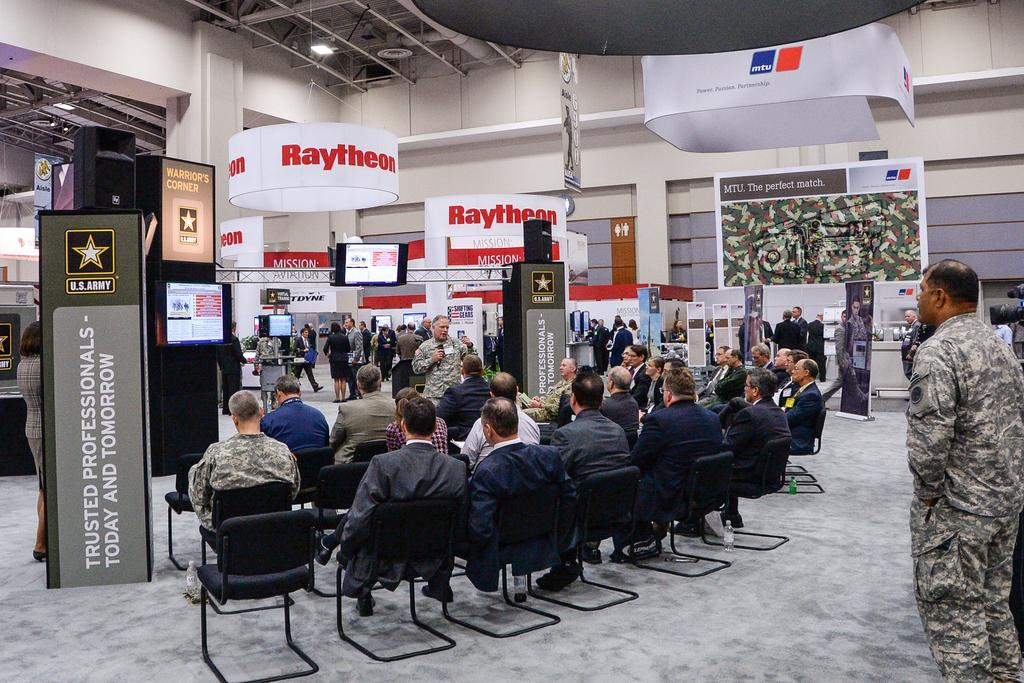Where is the image taken? The image is taken in a hall. What are the people in the image doing? The people are sitting on chairs. Who is the man holding a microphone and what is he doing? The man is holding a microphone and talking. What can be seen in the background of the image? There is a wall and a banner in the background. What type of reaction can be seen on the lawyer's face in the image? There is no lawyer present in the image, and therefore no reaction can be observed on a lawyer's face. 